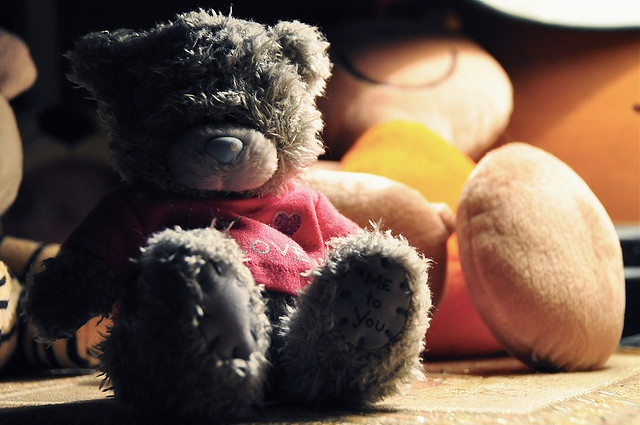Describe the objects in this image and their specific colors. I can see a teddy bear in black, gray, ivory, and darkgray tones in this image. 